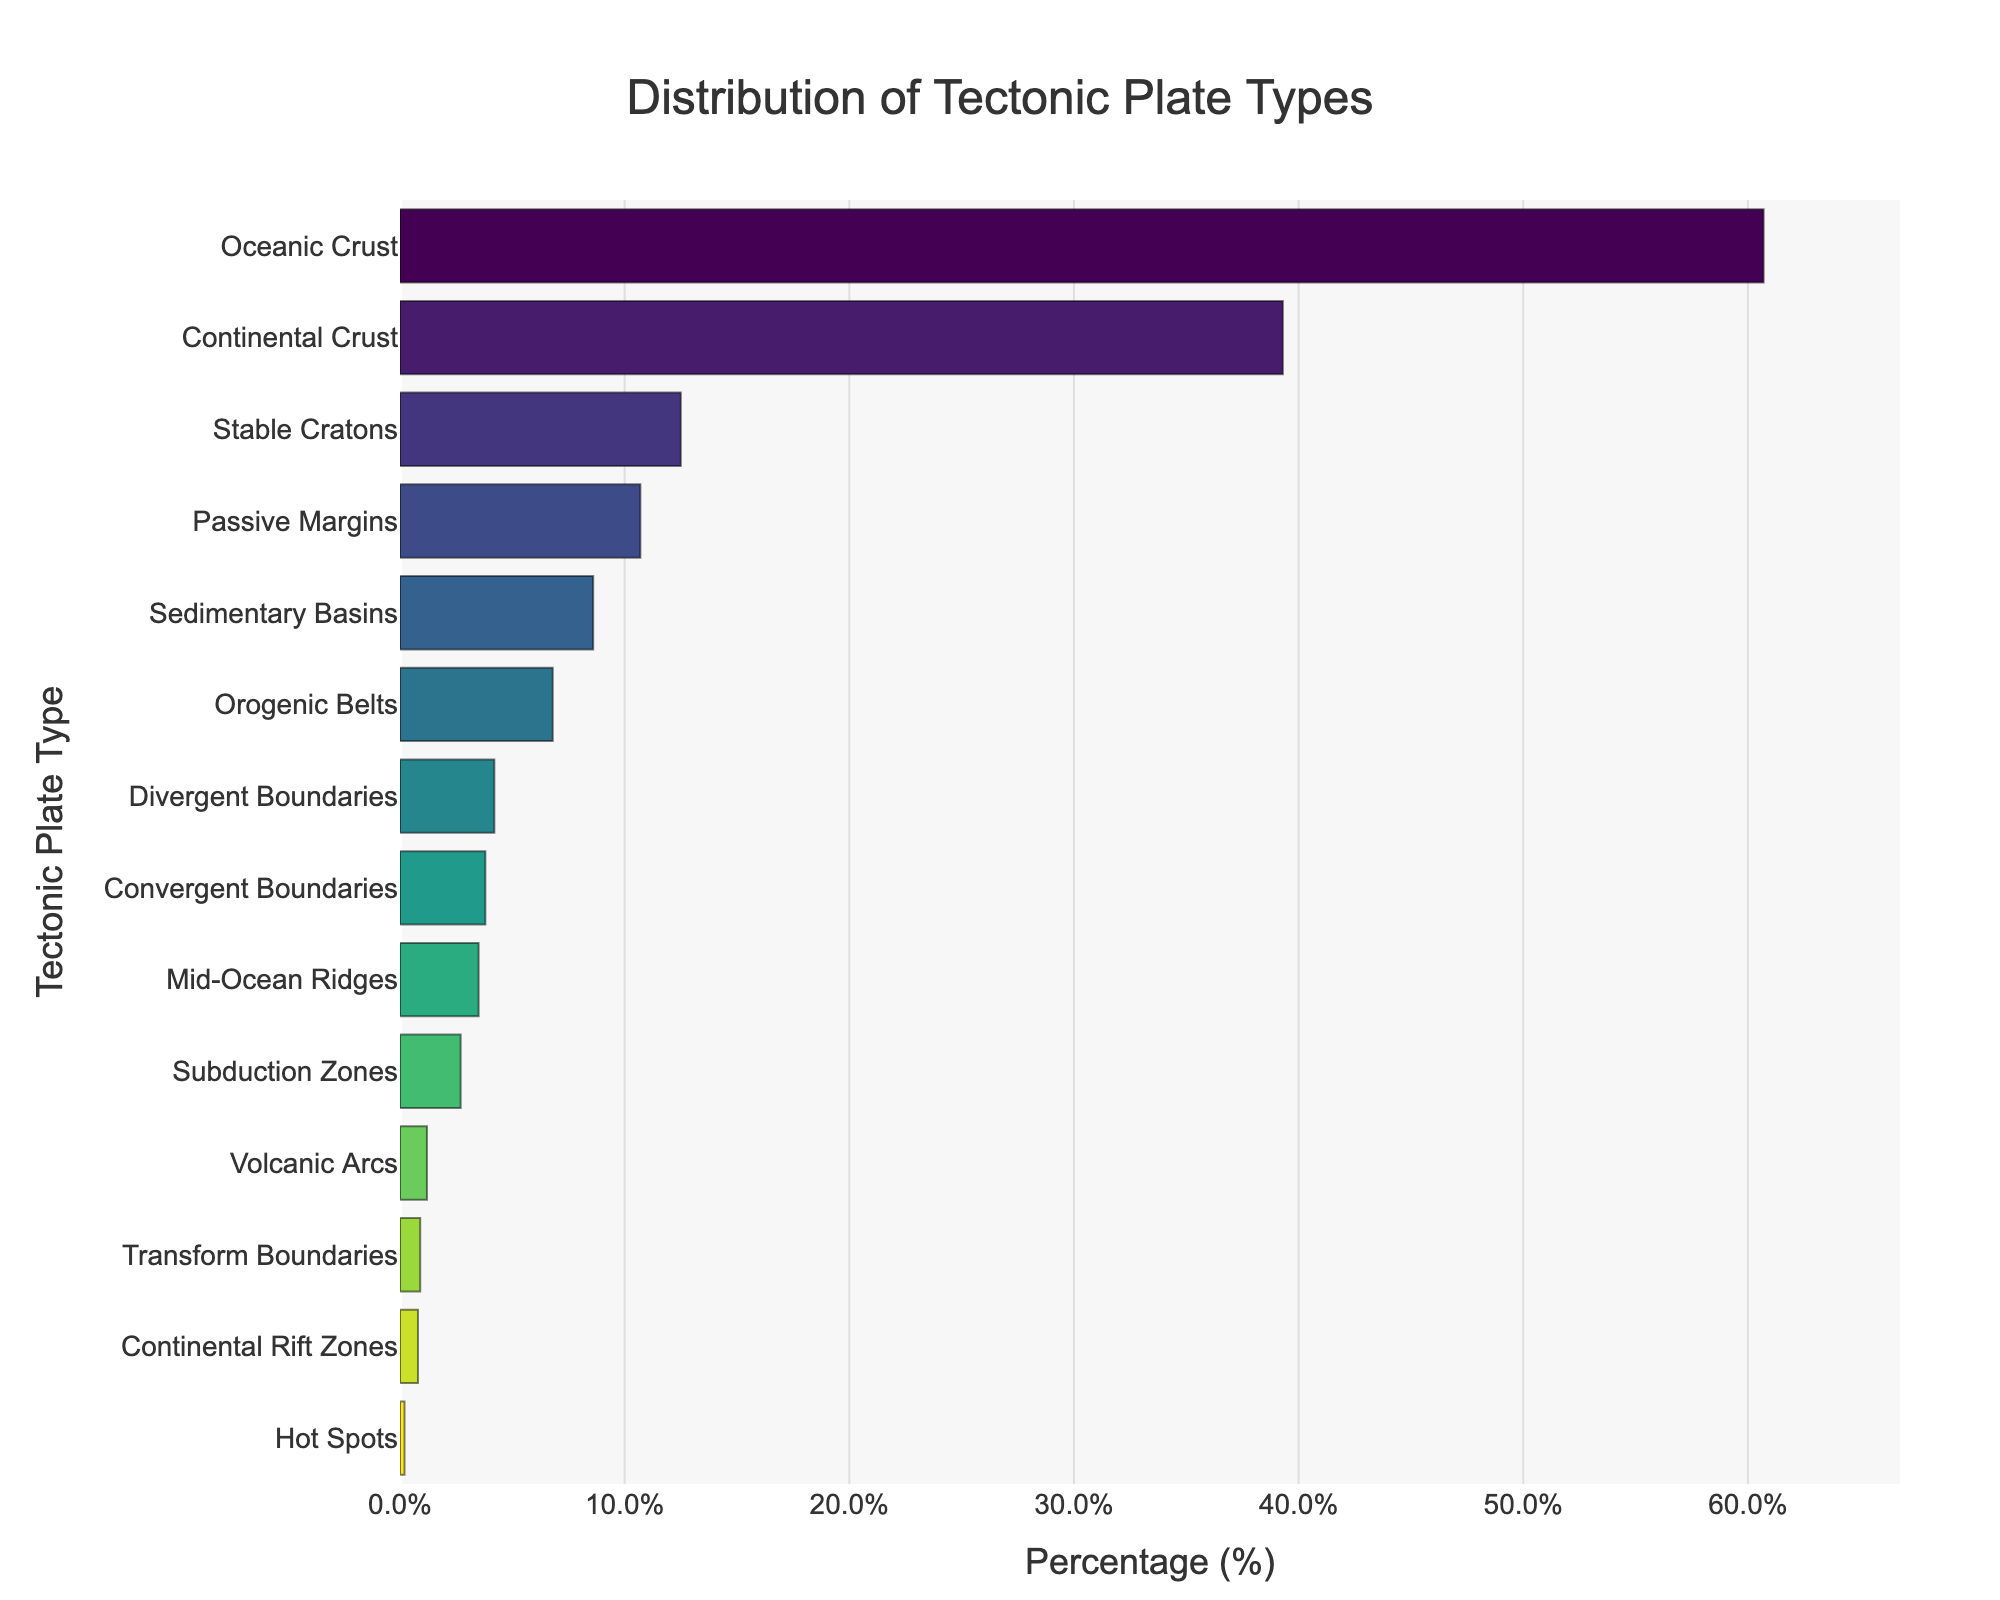Which tectonic plate type covers the largest percentage of Earth's surface? The bar chart shows percentage coverage by each tectonic plate type. The largest bar represents "Oceanic Crust" which covers 60.7%.
Answer: Oceanic Crust How much more percentage does Oceanic Crust cover compared to Continental Crust? The percentage for Oceanic Crust is 60.7% and for Continental Crust is 39.3%. Subtracting them: 60.7% - 39.3% = 21.4%.
Answer: 21.4% What is the total percentage covered by Passive Margins and Stable Cratons? The percentages for Passive Margins and Stable Cratons are 10.7% and 12.5%, respectively. Summing them: 10.7% + 12.5% = 23.2%.
Answer: 23.2% Out of Subduction Zones, Orogenic Belts, and Sedimentary Basins, which has the smallest percentage coverage? By comparing the percentages: Subduction Zones (2.7%), Orogenic Belts (6.8%), and Sedimentary Basins (8.6%), Subduction Zones covers the smallest.
Answer: Subduction Zones What is the cumulative percentage of the minor tectonic features: Divergent Boundaries, Transform Boundaries, Continental Rift Zones, Hot Spots, and Volcanic Arcs? Add the percentages for the minor features: 4.2% (Divergent Boundaries) + 0.9% (Transform Boundaries) + 0.8% (Continental Rift Zones) + 0.2% (Hot Spots) + 1.2% (Volcanic Arcs) = 7.3%.
Answer: 7.3% Which tectonic plate type is closest in percentage to the Orogenic Belts? The percentage for Orogenic Belts is 6.8%. The closest in percentage is Sedimentary Basins which is 8.6%. The difference is:
Answer: Sedimentary Basins Is the percentage of Mid-Ocean Ridges greater than the combined percentage of Transform Boundaries and Continental Rift Zones? Mid-Ocean Ridges have a percentage of 3.5%. Transform Boundaries and Continental Rift Zones combined equal 0.9% + 0.8% = 1.7%. 3.5% is greater than 1.7%.
Answer: Yes What is the average percentage coverage for Convergent Boundaries, Transform Boundaries, and Passive Margins? Percentages are: Convergent Boundaries (3.8%), Transform Boundaries (0.9%), Passive Margins (10.7%). Average: (3.8 + 0.9 + 10.7) / 3 = 5.13%.
Answer: 5.13% Which tectonic plate type ranked fourth in the percentage coverage? The sorted percentages show the following order: 1) Oceanic Crust, 2) Continental Crust, 3) Stable Cratons, 4) Passive Margins. Hence, Passive Margins are fourth.
Answer: Passive Margins 